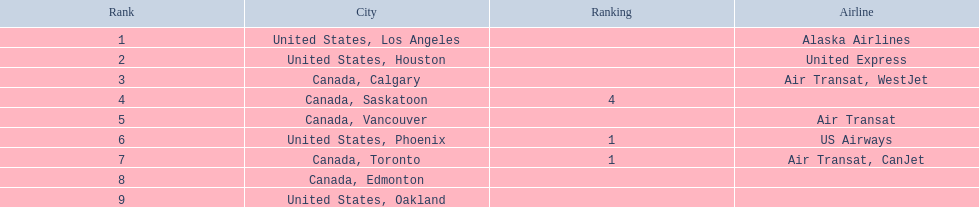Which airport has the least amount of passengers? 107. Help me parse the entirety of this table. {'header': ['Rank', 'City', 'Ranking', 'Airline'], 'rows': [['1', 'United States, Los Angeles', '', 'Alaska Airlines'], ['2', 'United States, Houston', '', 'United Express'], ['3', 'Canada, Calgary', '', 'Air Transat, WestJet'], ['4', 'Canada, Saskatoon', '4', ''], ['5', 'Canada, Vancouver', '', 'Air Transat'], ['6', 'United States, Phoenix', '1', 'US Airways'], ['7', 'Canada, Toronto', '1', 'Air Transat, CanJet'], ['8', 'Canada, Edmonton', '', ''], ['9', 'United States, Oakland', '', '']]} What airport has 107 passengers? United States, Oakland. 